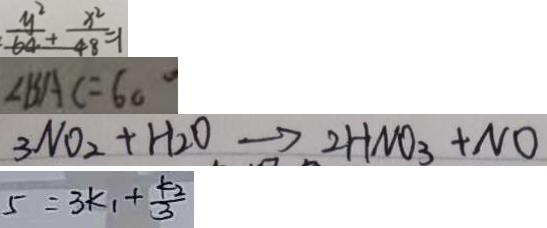<formula> <loc_0><loc_0><loc_500><loc_500>\frac { y ^ { 2 } } { 6 4 } + \frac { x ^ { 2 } } { 4 8 } = 1 
 \angle B A C = 6 0 ^ { \circ } 
 3 N O _ { 2 } + H _ { 2 } O \rightarrow 2 H N O _ { 3 } + N O 
 5 = 3 k _ { 1 } + \frac { k _ { 2 } } { 3 }</formula> 